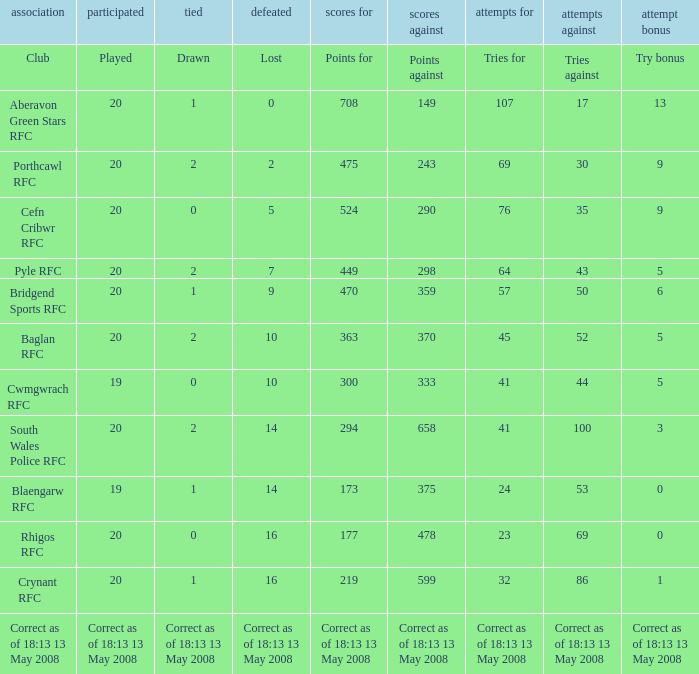What is the points when the try bonus is 1? 219.0. 